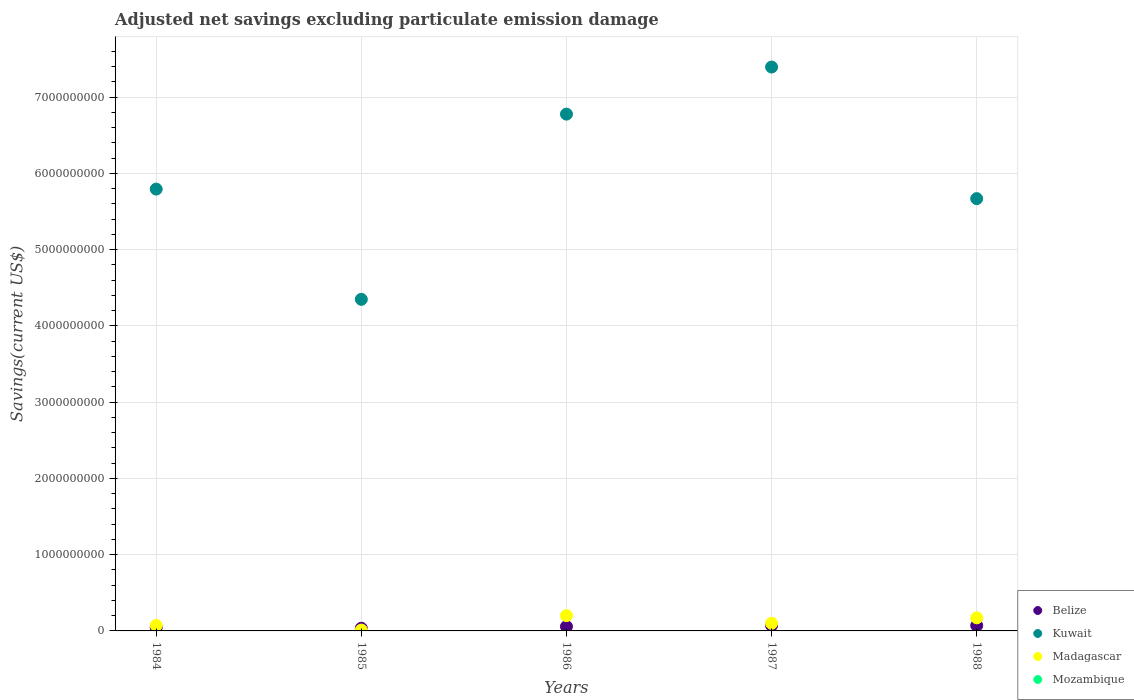How many different coloured dotlines are there?
Make the answer very short. 3. What is the adjusted net savings in Madagascar in 1985?
Provide a short and direct response. 1.12e+07. Across all years, what is the maximum adjusted net savings in Madagascar?
Offer a very short reply. 2.00e+08. Across all years, what is the minimum adjusted net savings in Belize?
Offer a terse response. 3.48e+07. In which year was the adjusted net savings in Madagascar maximum?
Your response must be concise. 1986. What is the total adjusted net savings in Belize in the graph?
Your answer should be compact. 2.78e+08. What is the difference between the adjusted net savings in Madagascar in 1984 and that in 1986?
Give a very brief answer. -1.29e+08. What is the difference between the adjusted net savings in Madagascar in 1988 and the adjusted net savings in Mozambique in 1986?
Give a very brief answer. 1.72e+08. What is the average adjusted net savings in Mozambique per year?
Your response must be concise. 0. In the year 1986, what is the difference between the adjusted net savings in Kuwait and adjusted net savings in Belize?
Make the answer very short. 6.72e+09. In how many years, is the adjusted net savings in Kuwait greater than 2800000000 US$?
Provide a short and direct response. 5. What is the ratio of the adjusted net savings in Madagascar in 1987 to that in 1988?
Provide a succinct answer. 0.58. Is the difference between the adjusted net savings in Kuwait in 1984 and 1986 greater than the difference between the adjusted net savings in Belize in 1984 and 1986?
Offer a terse response. No. What is the difference between the highest and the second highest adjusted net savings in Belize?
Ensure brevity in your answer.  8.86e+05. What is the difference between the highest and the lowest adjusted net savings in Kuwait?
Your response must be concise. 3.05e+09. In how many years, is the adjusted net savings in Madagascar greater than the average adjusted net savings in Madagascar taken over all years?
Make the answer very short. 2. Is the sum of the adjusted net savings in Madagascar in 1984 and 1987 greater than the maximum adjusted net savings in Kuwait across all years?
Your answer should be compact. No. Is it the case that in every year, the sum of the adjusted net savings in Mozambique and adjusted net savings in Belize  is greater than the adjusted net savings in Madagascar?
Your answer should be compact. No. Is the adjusted net savings in Madagascar strictly less than the adjusted net savings in Kuwait over the years?
Make the answer very short. Yes. How many dotlines are there?
Your response must be concise. 3. Are the values on the major ticks of Y-axis written in scientific E-notation?
Offer a very short reply. No. Does the graph contain any zero values?
Ensure brevity in your answer.  Yes. How are the legend labels stacked?
Offer a very short reply. Vertical. What is the title of the graph?
Give a very brief answer. Adjusted net savings excluding particulate emission damage. What is the label or title of the Y-axis?
Ensure brevity in your answer.  Savings(current US$). What is the Savings(current US$) in Belize in 1984?
Provide a short and direct response. 4.34e+07. What is the Savings(current US$) in Kuwait in 1984?
Your answer should be very brief. 5.79e+09. What is the Savings(current US$) in Madagascar in 1984?
Give a very brief answer. 7.12e+07. What is the Savings(current US$) in Belize in 1985?
Provide a short and direct response. 3.48e+07. What is the Savings(current US$) in Kuwait in 1985?
Give a very brief answer. 4.35e+09. What is the Savings(current US$) of Madagascar in 1985?
Your answer should be compact. 1.12e+07. What is the Savings(current US$) of Belize in 1986?
Give a very brief answer. 5.77e+07. What is the Savings(current US$) in Kuwait in 1986?
Provide a succinct answer. 6.78e+09. What is the Savings(current US$) in Madagascar in 1986?
Offer a very short reply. 2.00e+08. What is the Savings(current US$) of Belize in 1987?
Provide a short and direct response. 7.15e+07. What is the Savings(current US$) in Kuwait in 1987?
Keep it short and to the point. 7.39e+09. What is the Savings(current US$) in Madagascar in 1987?
Give a very brief answer. 9.97e+07. What is the Savings(current US$) in Belize in 1988?
Offer a very short reply. 7.06e+07. What is the Savings(current US$) in Kuwait in 1988?
Make the answer very short. 5.67e+09. What is the Savings(current US$) of Madagascar in 1988?
Provide a short and direct response. 1.72e+08. Across all years, what is the maximum Savings(current US$) of Belize?
Offer a very short reply. 7.15e+07. Across all years, what is the maximum Savings(current US$) of Kuwait?
Make the answer very short. 7.39e+09. Across all years, what is the maximum Savings(current US$) of Madagascar?
Provide a succinct answer. 2.00e+08. Across all years, what is the minimum Savings(current US$) of Belize?
Ensure brevity in your answer.  3.48e+07. Across all years, what is the minimum Savings(current US$) of Kuwait?
Your answer should be compact. 4.35e+09. Across all years, what is the minimum Savings(current US$) in Madagascar?
Give a very brief answer. 1.12e+07. What is the total Savings(current US$) in Belize in the graph?
Offer a very short reply. 2.78e+08. What is the total Savings(current US$) in Kuwait in the graph?
Your response must be concise. 3.00e+1. What is the total Savings(current US$) of Madagascar in the graph?
Provide a short and direct response. 5.54e+08. What is the difference between the Savings(current US$) of Belize in 1984 and that in 1985?
Offer a terse response. 8.60e+06. What is the difference between the Savings(current US$) in Kuwait in 1984 and that in 1985?
Your response must be concise. 1.45e+09. What is the difference between the Savings(current US$) in Madagascar in 1984 and that in 1985?
Your answer should be compact. 6.00e+07. What is the difference between the Savings(current US$) of Belize in 1984 and that in 1986?
Provide a short and direct response. -1.43e+07. What is the difference between the Savings(current US$) of Kuwait in 1984 and that in 1986?
Offer a terse response. -9.83e+08. What is the difference between the Savings(current US$) of Madagascar in 1984 and that in 1986?
Make the answer very short. -1.29e+08. What is the difference between the Savings(current US$) of Belize in 1984 and that in 1987?
Provide a short and direct response. -2.81e+07. What is the difference between the Savings(current US$) of Kuwait in 1984 and that in 1987?
Ensure brevity in your answer.  -1.60e+09. What is the difference between the Savings(current US$) of Madagascar in 1984 and that in 1987?
Your response must be concise. -2.84e+07. What is the difference between the Savings(current US$) in Belize in 1984 and that in 1988?
Your answer should be very brief. -2.72e+07. What is the difference between the Savings(current US$) in Kuwait in 1984 and that in 1988?
Provide a succinct answer. 1.25e+08. What is the difference between the Savings(current US$) in Madagascar in 1984 and that in 1988?
Give a very brief answer. -1.00e+08. What is the difference between the Savings(current US$) in Belize in 1985 and that in 1986?
Offer a very short reply. -2.29e+07. What is the difference between the Savings(current US$) of Kuwait in 1985 and that in 1986?
Offer a very short reply. -2.43e+09. What is the difference between the Savings(current US$) in Madagascar in 1985 and that in 1986?
Ensure brevity in your answer.  -1.89e+08. What is the difference between the Savings(current US$) in Belize in 1985 and that in 1987?
Make the answer very short. -3.67e+07. What is the difference between the Savings(current US$) of Kuwait in 1985 and that in 1987?
Give a very brief answer. -3.05e+09. What is the difference between the Savings(current US$) in Madagascar in 1985 and that in 1987?
Make the answer very short. -8.84e+07. What is the difference between the Savings(current US$) of Belize in 1985 and that in 1988?
Ensure brevity in your answer.  -3.58e+07. What is the difference between the Savings(current US$) of Kuwait in 1985 and that in 1988?
Keep it short and to the point. -1.32e+09. What is the difference between the Savings(current US$) in Madagascar in 1985 and that in 1988?
Offer a very short reply. -1.60e+08. What is the difference between the Savings(current US$) of Belize in 1986 and that in 1987?
Keep it short and to the point. -1.38e+07. What is the difference between the Savings(current US$) of Kuwait in 1986 and that in 1987?
Your answer should be very brief. -6.17e+08. What is the difference between the Savings(current US$) of Madagascar in 1986 and that in 1987?
Keep it short and to the point. 1.01e+08. What is the difference between the Savings(current US$) of Belize in 1986 and that in 1988?
Make the answer very short. -1.29e+07. What is the difference between the Savings(current US$) of Kuwait in 1986 and that in 1988?
Offer a terse response. 1.11e+09. What is the difference between the Savings(current US$) of Madagascar in 1986 and that in 1988?
Provide a short and direct response. 2.86e+07. What is the difference between the Savings(current US$) of Belize in 1987 and that in 1988?
Offer a very short reply. 8.86e+05. What is the difference between the Savings(current US$) in Kuwait in 1987 and that in 1988?
Give a very brief answer. 1.73e+09. What is the difference between the Savings(current US$) of Madagascar in 1987 and that in 1988?
Give a very brief answer. -7.19e+07. What is the difference between the Savings(current US$) of Belize in 1984 and the Savings(current US$) of Kuwait in 1985?
Keep it short and to the point. -4.30e+09. What is the difference between the Savings(current US$) in Belize in 1984 and the Savings(current US$) in Madagascar in 1985?
Ensure brevity in your answer.  3.21e+07. What is the difference between the Savings(current US$) in Kuwait in 1984 and the Savings(current US$) in Madagascar in 1985?
Ensure brevity in your answer.  5.78e+09. What is the difference between the Savings(current US$) of Belize in 1984 and the Savings(current US$) of Kuwait in 1986?
Your answer should be very brief. -6.73e+09. What is the difference between the Savings(current US$) in Belize in 1984 and the Savings(current US$) in Madagascar in 1986?
Your answer should be very brief. -1.57e+08. What is the difference between the Savings(current US$) in Kuwait in 1984 and the Savings(current US$) in Madagascar in 1986?
Make the answer very short. 5.59e+09. What is the difference between the Savings(current US$) in Belize in 1984 and the Savings(current US$) in Kuwait in 1987?
Your response must be concise. -7.35e+09. What is the difference between the Savings(current US$) in Belize in 1984 and the Savings(current US$) in Madagascar in 1987?
Offer a very short reply. -5.63e+07. What is the difference between the Savings(current US$) of Kuwait in 1984 and the Savings(current US$) of Madagascar in 1987?
Make the answer very short. 5.69e+09. What is the difference between the Savings(current US$) in Belize in 1984 and the Savings(current US$) in Kuwait in 1988?
Keep it short and to the point. -5.62e+09. What is the difference between the Savings(current US$) in Belize in 1984 and the Savings(current US$) in Madagascar in 1988?
Provide a succinct answer. -1.28e+08. What is the difference between the Savings(current US$) of Kuwait in 1984 and the Savings(current US$) of Madagascar in 1988?
Offer a very short reply. 5.62e+09. What is the difference between the Savings(current US$) in Belize in 1985 and the Savings(current US$) in Kuwait in 1986?
Keep it short and to the point. -6.74e+09. What is the difference between the Savings(current US$) in Belize in 1985 and the Savings(current US$) in Madagascar in 1986?
Give a very brief answer. -1.65e+08. What is the difference between the Savings(current US$) of Kuwait in 1985 and the Savings(current US$) of Madagascar in 1986?
Provide a succinct answer. 4.15e+09. What is the difference between the Savings(current US$) in Belize in 1985 and the Savings(current US$) in Kuwait in 1987?
Offer a terse response. -7.36e+09. What is the difference between the Savings(current US$) of Belize in 1985 and the Savings(current US$) of Madagascar in 1987?
Make the answer very short. -6.49e+07. What is the difference between the Savings(current US$) of Kuwait in 1985 and the Savings(current US$) of Madagascar in 1987?
Offer a terse response. 4.25e+09. What is the difference between the Savings(current US$) in Belize in 1985 and the Savings(current US$) in Kuwait in 1988?
Your answer should be very brief. -5.63e+09. What is the difference between the Savings(current US$) in Belize in 1985 and the Savings(current US$) in Madagascar in 1988?
Keep it short and to the point. -1.37e+08. What is the difference between the Savings(current US$) of Kuwait in 1985 and the Savings(current US$) of Madagascar in 1988?
Offer a terse response. 4.18e+09. What is the difference between the Savings(current US$) of Belize in 1986 and the Savings(current US$) of Kuwait in 1987?
Ensure brevity in your answer.  -7.34e+09. What is the difference between the Savings(current US$) in Belize in 1986 and the Savings(current US$) in Madagascar in 1987?
Make the answer very short. -4.20e+07. What is the difference between the Savings(current US$) in Kuwait in 1986 and the Savings(current US$) in Madagascar in 1987?
Keep it short and to the point. 6.68e+09. What is the difference between the Savings(current US$) in Belize in 1986 and the Savings(current US$) in Kuwait in 1988?
Give a very brief answer. -5.61e+09. What is the difference between the Savings(current US$) in Belize in 1986 and the Savings(current US$) in Madagascar in 1988?
Your answer should be very brief. -1.14e+08. What is the difference between the Savings(current US$) in Kuwait in 1986 and the Savings(current US$) in Madagascar in 1988?
Give a very brief answer. 6.60e+09. What is the difference between the Savings(current US$) of Belize in 1987 and the Savings(current US$) of Kuwait in 1988?
Offer a terse response. -5.60e+09. What is the difference between the Savings(current US$) of Belize in 1987 and the Savings(current US$) of Madagascar in 1988?
Offer a terse response. -1.00e+08. What is the difference between the Savings(current US$) in Kuwait in 1987 and the Savings(current US$) in Madagascar in 1988?
Keep it short and to the point. 7.22e+09. What is the average Savings(current US$) of Belize per year?
Provide a succinct answer. 5.56e+07. What is the average Savings(current US$) of Kuwait per year?
Provide a short and direct response. 6.00e+09. What is the average Savings(current US$) in Madagascar per year?
Provide a succinct answer. 1.11e+08. In the year 1984, what is the difference between the Savings(current US$) in Belize and Savings(current US$) in Kuwait?
Provide a short and direct response. -5.75e+09. In the year 1984, what is the difference between the Savings(current US$) of Belize and Savings(current US$) of Madagascar?
Provide a succinct answer. -2.78e+07. In the year 1984, what is the difference between the Savings(current US$) of Kuwait and Savings(current US$) of Madagascar?
Keep it short and to the point. 5.72e+09. In the year 1985, what is the difference between the Savings(current US$) in Belize and Savings(current US$) in Kuwait?
Your answer should be very brief. -4.31e+09. In the year 1985, what is the difference between the Savings(current US$) of Belize and Savings(current US$) of Madagascar?
Offer a terse response. 2.35e+07. In the year 1985, what is the difference between the Savings(current US$) in Kuwait and Savings(current US$) in Madagascar?
Provide a short and direct response. 4.34e+09. In the year 1986, what is the difference between the Savings(current US$) in Belize and Savings(current US$) in Kuwait?
Your answer should be compact. -6.72e+09. In the year 1986, what is the difference between the Savings(current US$) of Belize and Savings(current US$) of Madagascar?
Your answer should be very brief. -1.43e+08. In the year 1986, what is the difference between the Savings(current US$) of Kuwait and Savings(current US$) of Madagascar?
Provide a short and direct response. 6.58e+09. In the year 1987, what is the difference between the Savings(current US$) in Belize and Savings(current US$) in Kuwait?
Your answer should be compact. -7.32e+09. In the year 1987, what is the difference between the Savings(current US$) in Belize and Savings(current US$) in Madagascar?
Ensure brevity in your answer.  -2.82e+07. In the year 1987, what is the difference between the Savings(current US$) of Kuwait and Savings(current US$) of Madagascar?
Make the answer very short. 7.29e+09. In the year 1988, what is the difference between the Savings(current US$) in Belize and Savings(current US$) in Kuwait?
Give a very brief answer. -5.60e+09. In the year 1988, what is the difference between the Savings(current US$) in Belize and Savings(current US$) in Madagascar?
Provide a succinct answer. -1.01e+08. In the year 1988, what is the difference between the Savings(current US$) in Kuwait and Savings(current US$) in Madagascar?
Offer a terse response. 5.50e+09. What is the ratio of the Savings(current US$) of Belize in 1984 to that in 1985?
Offer a terse response. 1.25. What is the ratio of the Savings(current US$) of Kuwait in 1984 to that in 1985?
Your answer should be very brief. 1.33. What is the ratio of the Savings(current US$) of Madagascar in 1984 to that in 1985?
Offer a very short reply. 6.34. What is the ratio of the Savings(current US$) of Belize in 1984 to that in 1986?
Keep it short and to the point. 0.75. What is the ratio of the Savings(current US$) of Kuwait in 1984 to that in 1986?
Provide a succinct answer. 0.85. What is the ratio of the Savings(current US$) of Madagascar in 1984 to that in 1986?
Provide a short and direct response. 0.36. What is the ratio of the Savings(current US$) of Belize in 1984 to that in 1987?
Give a very brief answer. 0.61. What is the ratio of the Savings(current US$) of Kuwait in 1984 to that in 1987?
Provide a succinct answer. 0.78. What is the ratio of the Savings(current US$) of Madagascar in 1984 to that in 1987?
Your answer should be very brief. 0.71. What is the ratio of the Savings(current US$) in Belize in 1984 to that in 1988?
Provide a short and direct response. 0.61. What is the ratio of the Savings(current US$) in Madagascar in 1984 to that in 1988?
Give a very brief answer. 0.42. What is the ratio of the Savings(current US$) in Belize in 1985 to that in 1986?
Ensure brevity in your answer.  0.6. What is the ratio of the Savings(current US$) in Kuwait in 1985 to that in 1986?
Ensure brevity in your answer.  0.64. What is the ratio of the Savings(current US$) in Madagascar in 1985 to that in 1986?
Offer a very short reply. 0.06. What is the ratio of the Savings(current US$) of Belize in 1985 to that in 1987?
Your response must be concise. 0.49. What is the ratio of the Savings(current US$) of Kuwait in 1985 to that in 1987?
Offer a terse response. 0.59. What is the ratio of the Savings(current US$) of Madagascar in 1985 to that in 1987?
Keep it short and to the point. 0.11. What is the ratio of the Savings(current US$) in Belize in 1985 to that in 1988?
Provide a succinct answer. 0.49. What is the ratio of the Savings(current US$) of Kuwait in 1985 to that in 1988?
Keep it short and to the point. 0.77. What is the ratio of the Savings(current US$) in Madagascar in 1985 to that in 1988?
Your response must be concise. 0.07. What is the ratio of the Savings(current US$) in Belize in 1986 to that in 1987?
Provide a short and direct response. 0.81. What is the ratio of the Savings(current US$) in Kuwait in 1986 to that in 1987?
Your answer should be compact. 0.92. What is the ratio of the Savings(current US$) of Madagascar in 1986 to that in 1987?
Make the answer very short. 2.01. What is the ratio of the Savings(current US$) in Belize in 1986 to that in 1988?
Give a very brief answer. 0.82. What is the ratio of the Savings(current US$) in Kuwait in 1986 to that in 1988?
Your response must be concise. 1.2. What is the ratio of the Savings(current US$) in Madagascar in 1986 to that in 1988?
Keep it short and to the point. 1.17. What is the ratio of the Savings(current US$) in Belize in 1987 to that in 1988?
Offer a very short reply. 1.01. What is the ratio of the Savings(current US$) of Kuwait in 1987 to that in 1988?
Give a very brief answer. 1.3. What is the ratio of the Savings(current US$) of Madagascar in 1987 to that in 1988?
Give a very brief answer. 0.58. What is the difference between the highest and the second highest Savings(current US$) of Belize?
Keep it short and to the point. 8.86e+05. What is the difference between the highest and the second highest Savings(current US$) of Kuwait?
Make the answer very short. 6.17e+08. What is the difference between the highest and the second highest Savings(current US$) of Madagascar?
Keep it short and to the point. 2.86e+07. What is the difference between the highest and the lowest Savings(current US$) in Belize?
Give a very brief answer. 3.67e+07. What is the difference between the highest and the lowest Savings(current US$) in Kuwait?
Your response must be concise. 3.05e+09. What is the difference between the highest and the lowest Savings(current US$) in Madagascar?
Your response must be concise. 1.89e+08. 